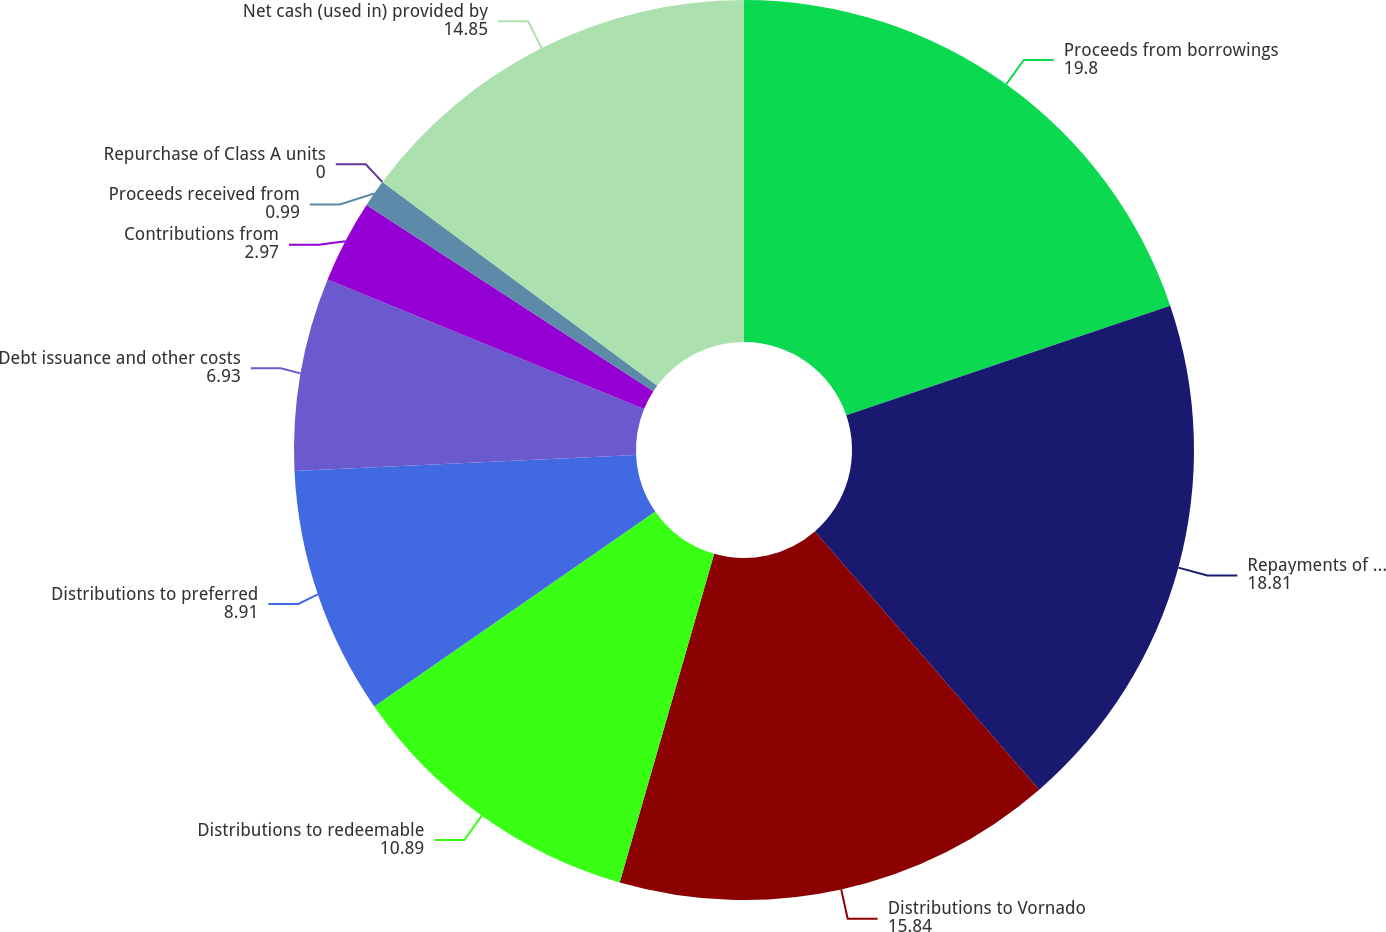Convert chart to OTSL. <chart><loc_0><loc_0><loc_500><loc_500><pie_chart><fcel>Proceeds from borrowings<fcel>Repayments of borrowings<fcel>Distributions to Vornado<fcel>Distributions to redeemable<fcel>Distributions to preferred<fcel>Debt issuance and other costs<fcel>Contributions from<fcel>Proceeds received from<fcel>Repurchase of Class A units<fcel>Net cash (used in) provided by<nl><fcel>19.8%<fcel>18.81%<fcel>15.84%<fcel>10.89%<fcel>8.91%<fcel>6.93%<fcel>2.97%<fcel>0.99%<fcel>0.0%<fcel>14.85%<nl></chart> 